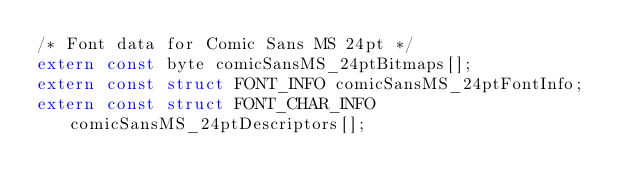<code> <loc_0><loc_0><loc_500><loc_500><_C_>/* Font data for Comic Sans MS 24pt */
extern const byte comicSansMS_24ptBitmaps[];
extern const struct FONT_INFO comicSansMS_24ptFontInfo;
extern const struct FONT_CHAR_INFO comicSansMS_24ptDescriptors[];

</code> 